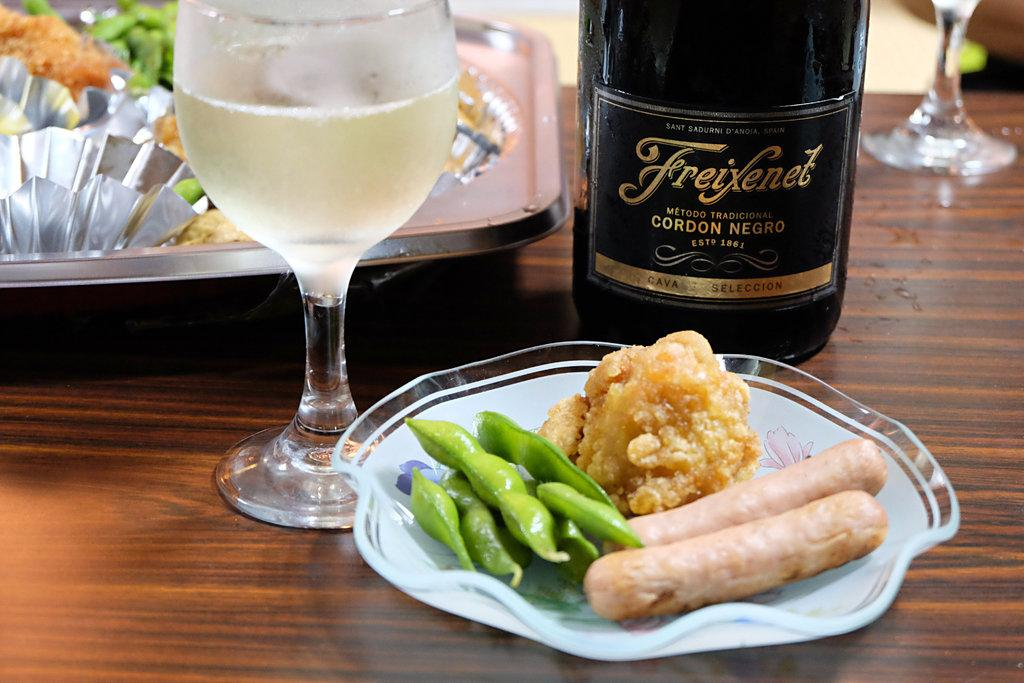Provide a one-sentence caption for the provided image. A bottle of Freixenet Cordon Negro is next to a plate of food. 